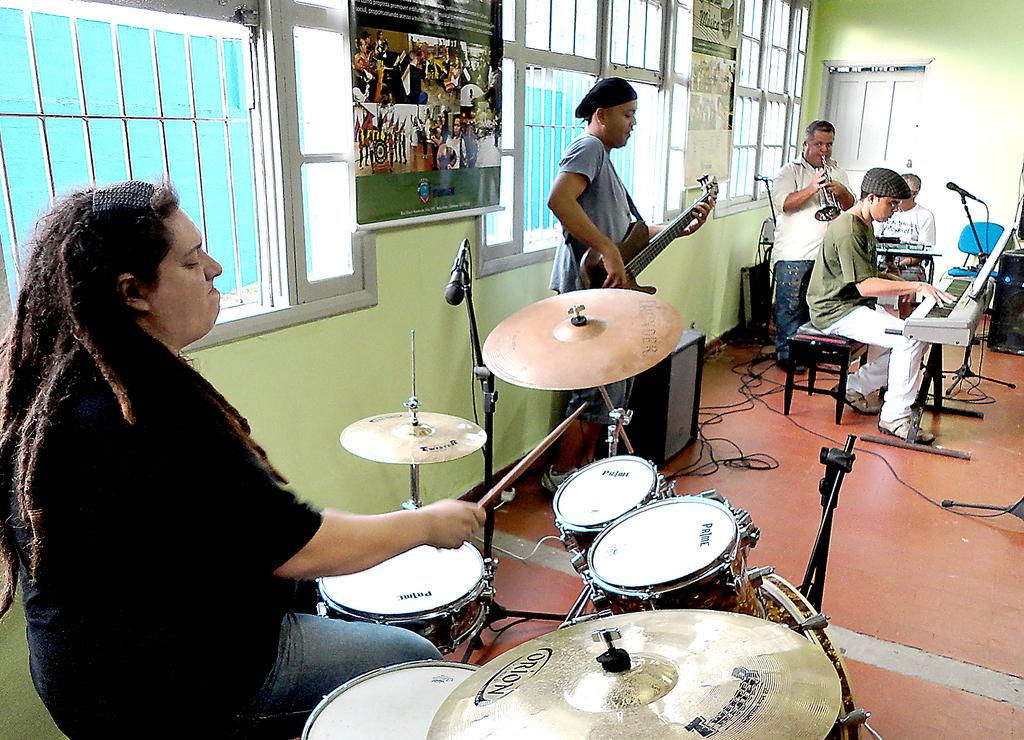How many people are in the image? There are five people in the image. What are the people doing in the image? The people are playing musical instruments. Can you describe the specific instruments being played by the individuals? One person is playing a snare drum with drum sticks, one person is playing a piano, and one person is playing a saxophone. What type of amusement can be seen in the image? There is no amusement park or ride present in the image; it features people playing musical instruments. What idea is being expressed by the dolls in the image? There are no dolls present in the image. 